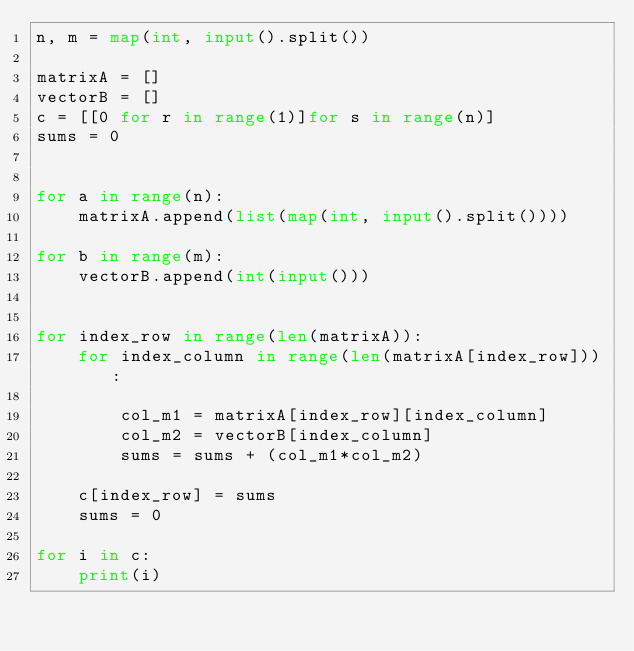Convert code to text. <code><loc_0><loc_0><loc_500><loc_500><_Python_>n, m = map(int, input().split())

matrixA = []
vectorB = []
c = [[0 for r in range(1)]for s in range(n)]
sums = 0


for a in range(n):
    matrixA.append(list(map(int, input().split())))

for b in range(m):
    vectorB.append(int(input()))


for index_row in range(len(matrixA)):
    for index_column in range(len(matrixA[index_row])):

        col_m1 = matrixA[index_row][index_column]
        col_m2 = vectorB[index_column]
        sums = sums + (col_m1*col_m2)
  
    c[index_row] = sums
    sums = 0

for i in c:
    print(i)
</code> 